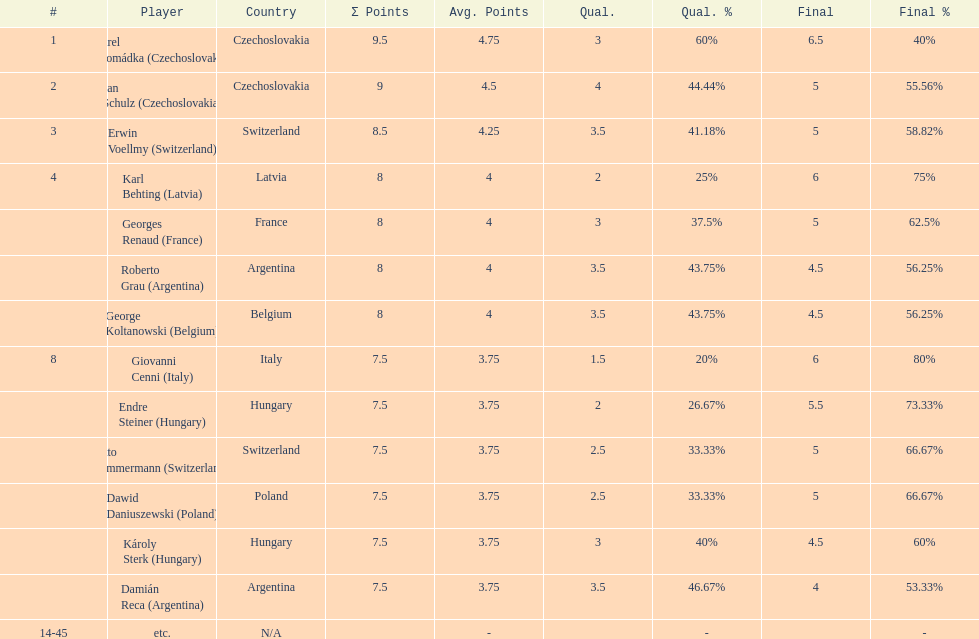How many players had final scores higher than 5? 4. 